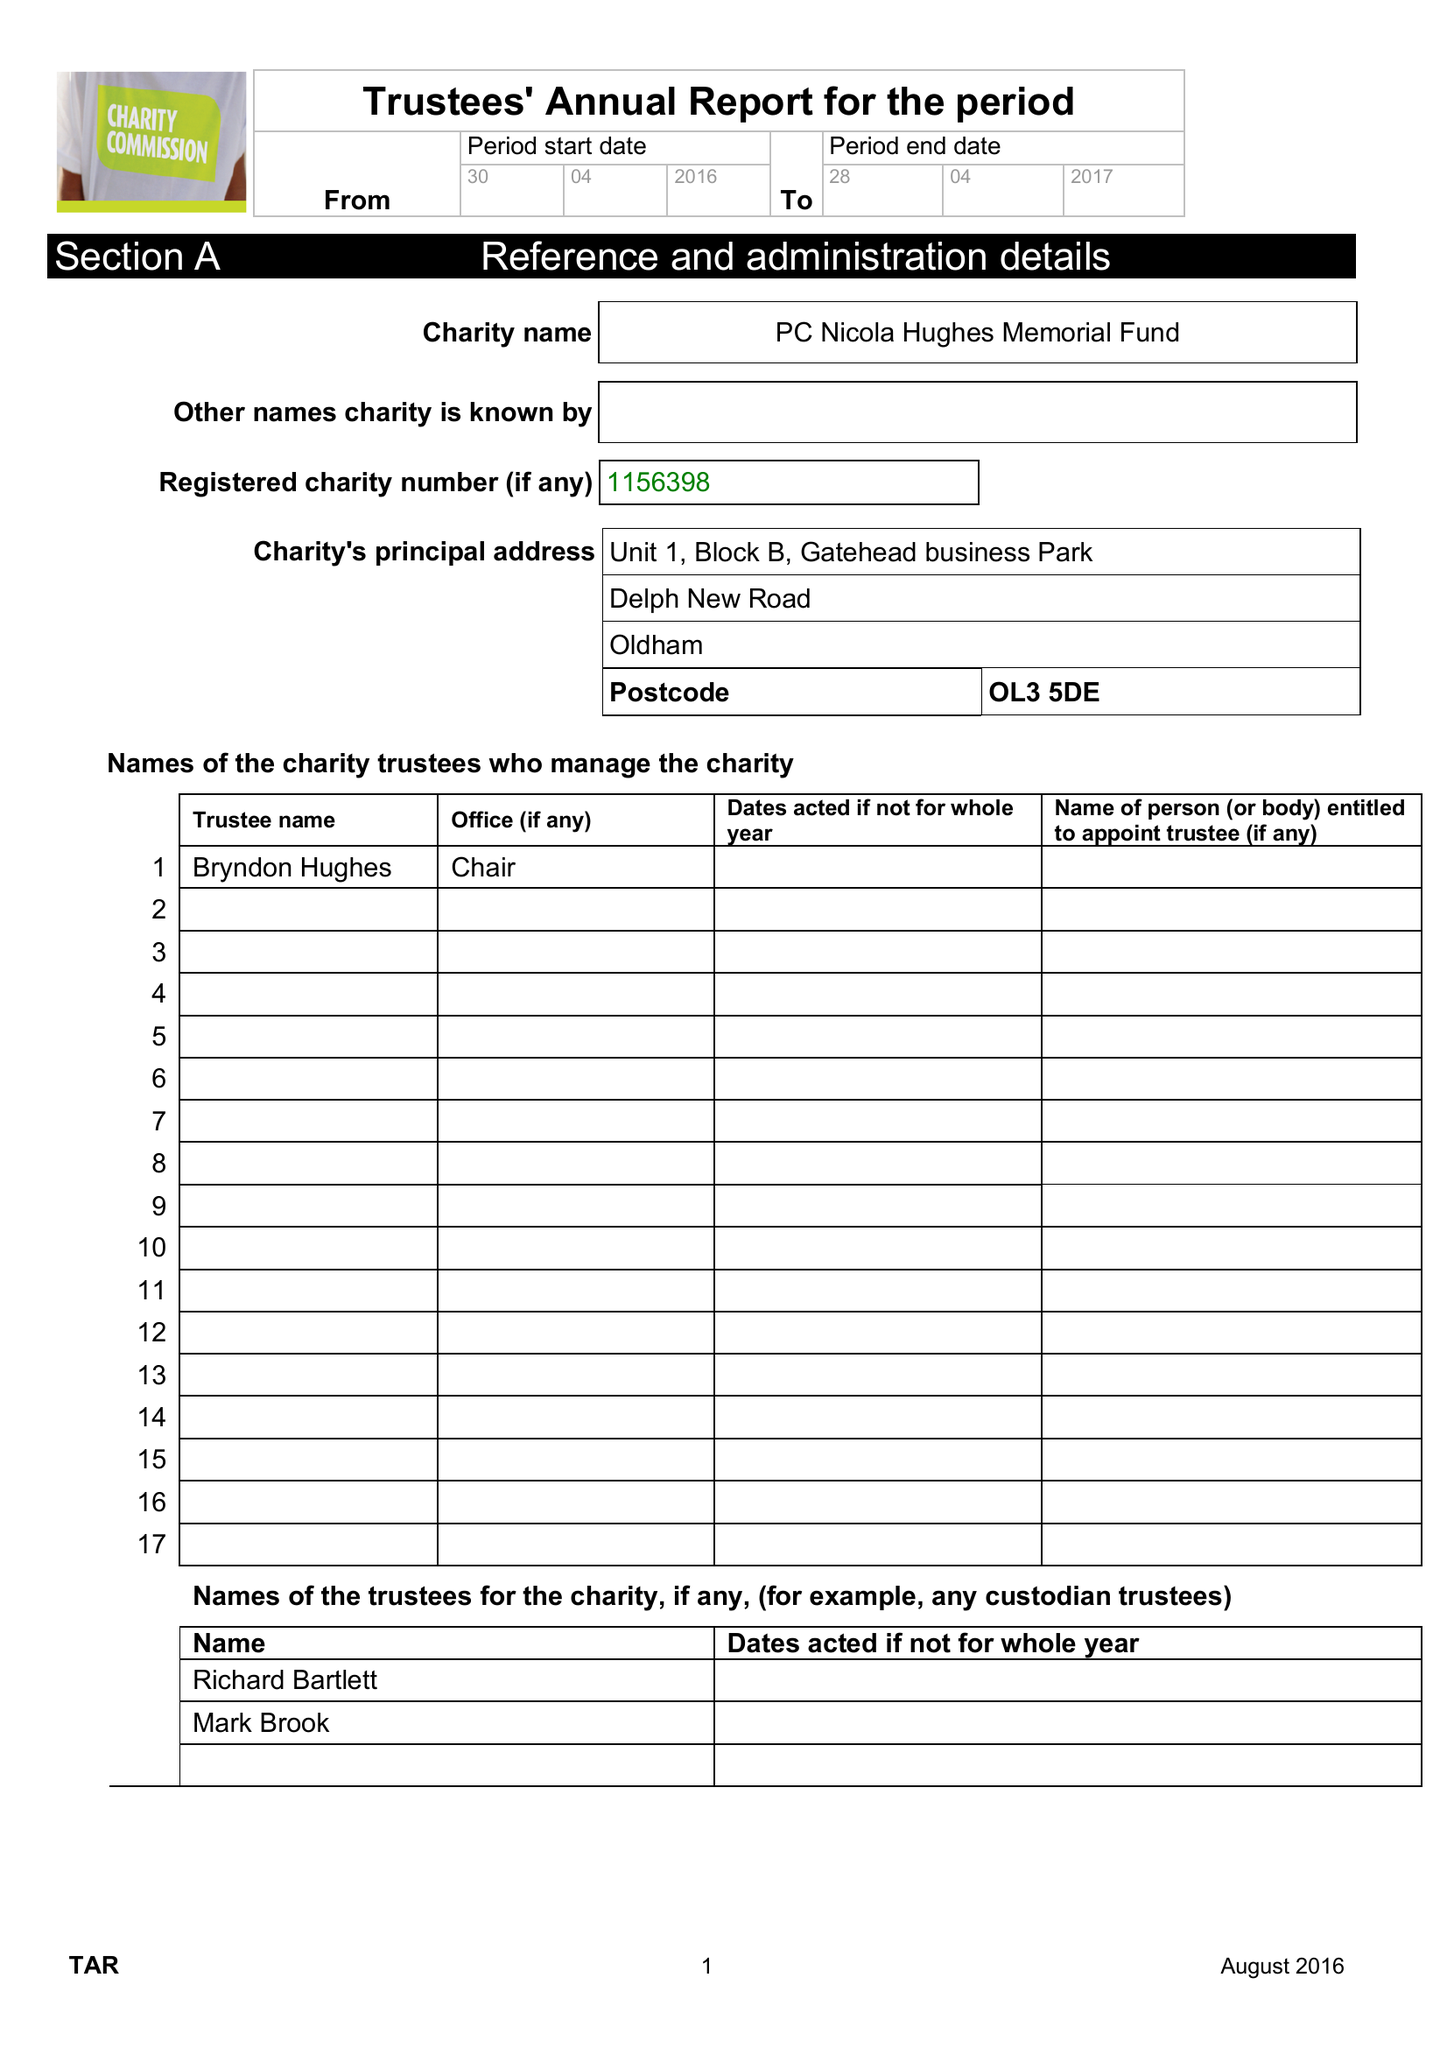What is the value for the address__street_line?
Answer the question using a single word or phrase. DELPH NEW ROAD 